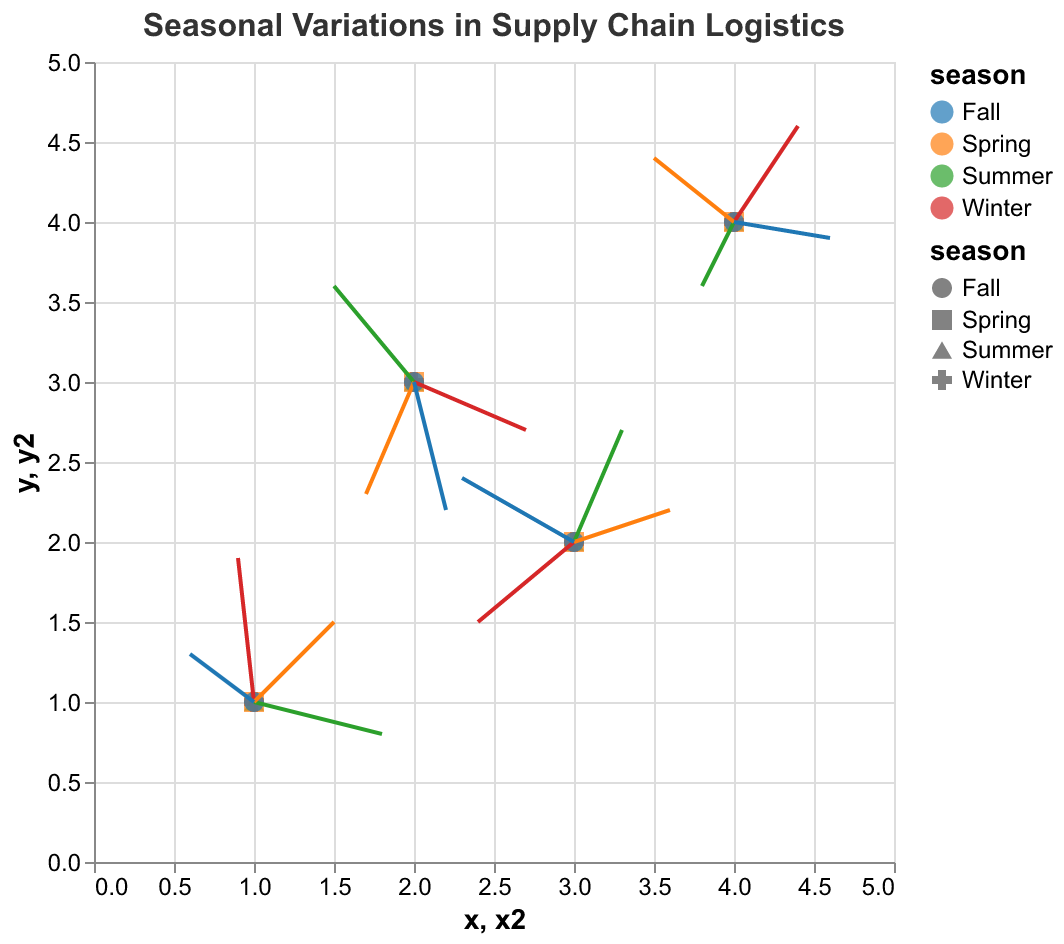What is the title of the figure? The title is located at the top of the figure, centered, and in larger, bold text.
Answer: Seasonal Variations in Supply Chain Logistics How many seasons are represented in the figure? Each color and shape represents a different season. There are four distinct colors and shapes in the legend for the figure.
Answer: Four Which season shows the largest horizontal displacement in any direction? To find this, look for the longest arrows in the horizontal direction (the 'u' component) for each season. Winter has a point (x=2, y=3) with u=0.7.
Answer: Winter What are the coordinates of the data point in Spring that moves most upwards? Upward movement means a positive 'v' component. For Spring, the highest 'v' value is at (x=1, y=1) with v=0.5.
Answer: (1, 1) Which data points in Summer have negative vertical displacement? Vertical displacement is given by ‘v’, negative displacement means ‘v’ is less than 0. There are two points in Summer with negative 'v': (x=1, y=1) with v=-0.2, and (x=4, y=4) with v=-0.4.
Answer: (1, 1) and (4, 4) For Fall, what is the mathematical average of horizontal displacement ‘u’ values? Add the ‘u’ values for Fall's data points and divide by the number of points. Calculations: (-0.4 + 0.2 - 0.7 + 0.6)/4 = -0.075.
Answer: -0.075 Do any data points in Winter show movement towards the top-left (quadrant II) of the coordinate system? Movement to the top-left means a negative 'u' and a positive 'v'. For Winter: None of the points have a combination of negative 'u' and positive 'v'.
Answer: No Compare the vertical displacements of the points at (3,2) between Summer and Winter. Which is greater? For (3, 2) in Summer, v is 0.7. In Winter, v is -0.5. 0.7 is greater than -0.5.
Answer: Summer 